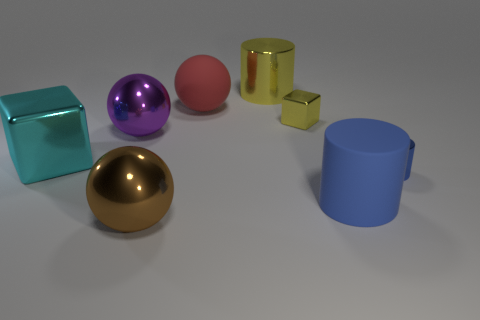What size is the cyan cube?
Offer a terse response. Large. There is a thing that is the same color as the large matte cylinder; what is it made of?
Offer a terse response. Metal. How many small shiny objects are the same color as the rubber cylinder?
Your response must be concise. 1. Do the red object and the yellow shiny cylinder have the same size?
Your response must be concise. Yes. There is a red sphere to the left of the metal cube that is on the right side of the red object; how big is it?
Your response must be concise. Large. Does the large rubber cylinder have the same color as the rubber object that is behind the large purple shiny thing?
Provide a short and direct response. No. Is there a cyan metal sphere of the same size as the purple sphere?
Your response must be concise. No. There is a cube to the right of the big cyan thing; what is its size?
Your answer should be very brief. Small. There is a big cylinder that is in front of the purple metal sphere; are there any blue metal things on the left side of it?
Your response must be concise. No. What number of other objects are the same shape as the red thing?
Provide a succinct answer. 2. 